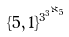<formula> <loc_0><loc_0><loc_500><loc_500>\{ 5 , 1 \} ^ { 3 ^ { 3 ^ { \aleph _ { 5 } } } }</formula> 